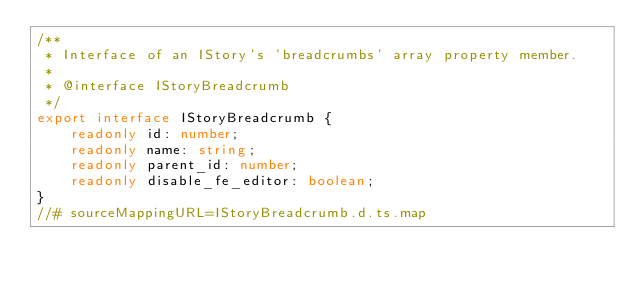<code> <loc_0><loc_0><loc_500><loc_500><_TypeScript_>/**
 * Interface of an IStory's 'breadcrumbs' array property member.
 *
 * @interface IStoryBreadcrumb
 */
export interface IStoryBreadcrumb {
    readonly id: number;
    readonly name: string;
    readonly parent_id: number;
    readonly disable_fe_editor: boolean;
}
//# sourceMappingURL=IStoryBreadcrumb.d.ts.map</code> 